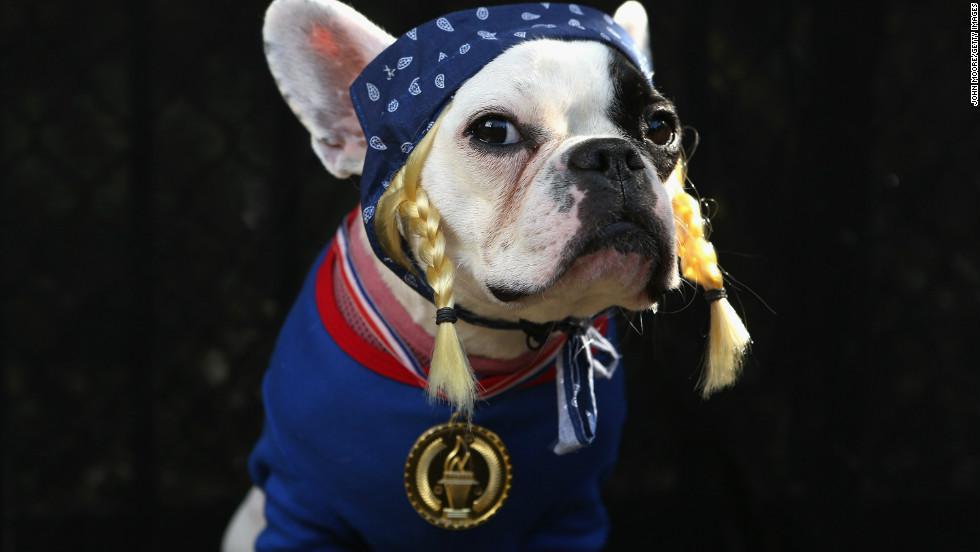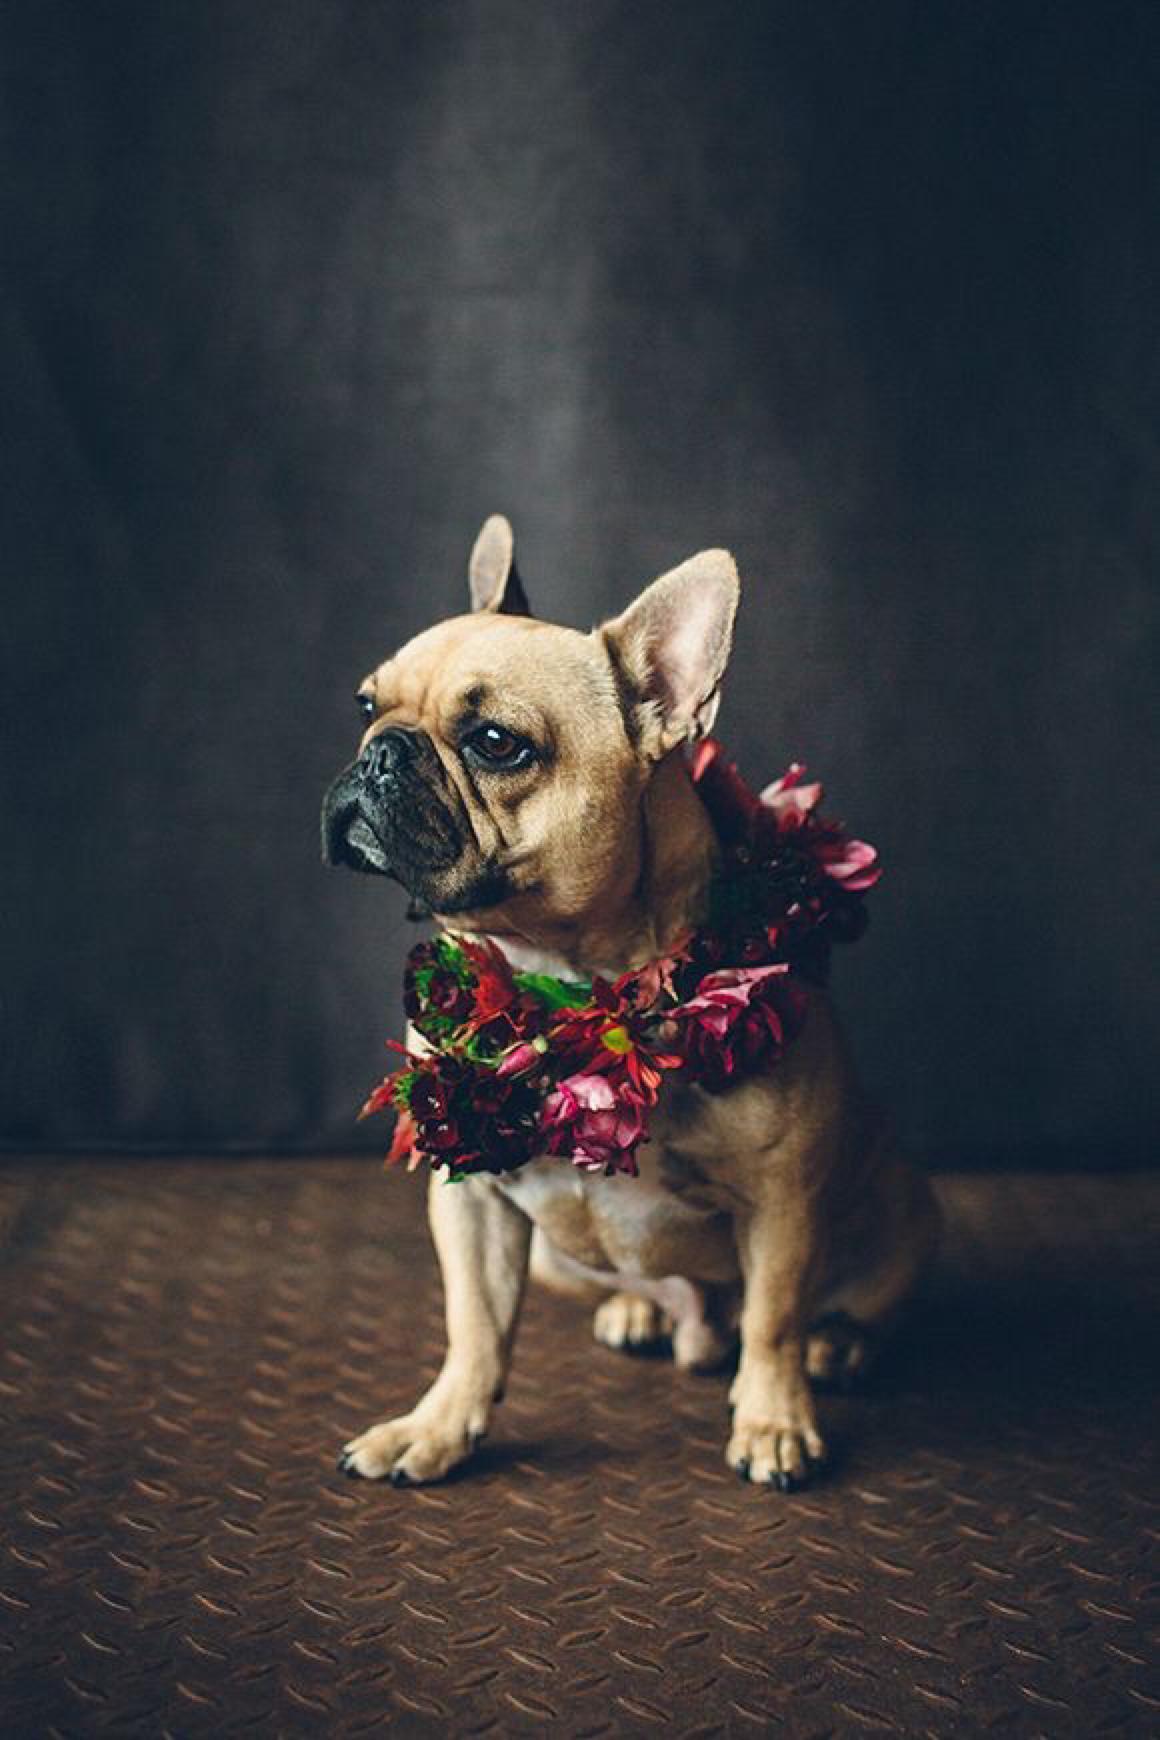The first image is the image on the left, the second image is the image on the right. For the images shown, is this caption "Each dog is wearing some kind of costume." true? Answer yes or no. Yes. The first image is the image on the left, the second image is the image on the right. Analyze the images presented: Is the assertion "In one of the image the dog is looking to the right." valid? Answer yes or no. Yes. 